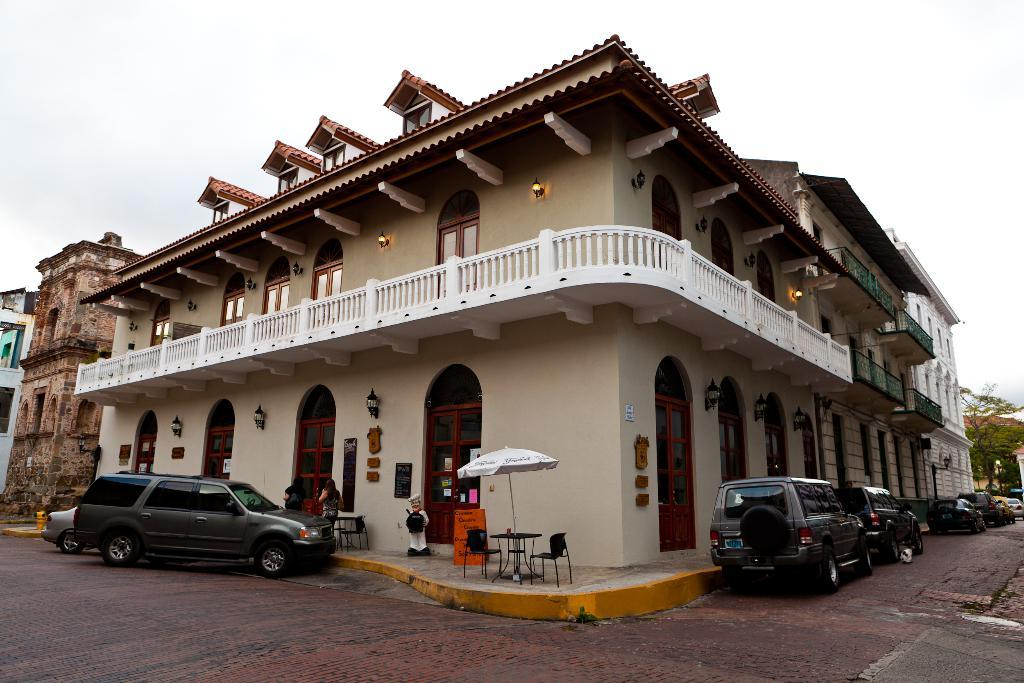How many cars can be seen on the left side of the image? There are two cars parked on the left side of the image. Are there any cars parked on the right side of the image? Yes, there are cars parked on the right side of the image. What is located in the middle of the image? There is a house in the middle of the image. What type of shock can be seen in the image? There is no shock present in the image. Are there any slaves depicted in the image? There is no mention of slaves or any related context in the image. 